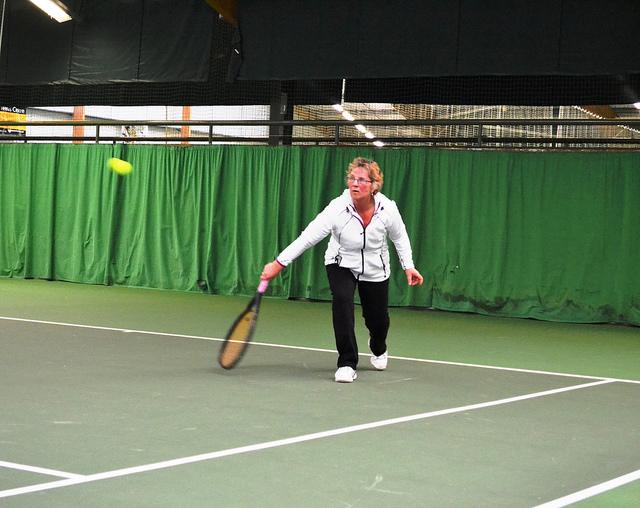Is the woman barefooted?
Be succinct. No. What sport does this woman appear to be playing?
Short answer required. Tennis. Is this woman in her twenties?
Short answer required. No. 